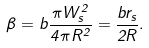<formula> <loc_0><loc_0><loc_500><loc_500>\beta = b \frac { \pi W _ { s } ^ { 2 } } { 4 \pi R ^ { 2 } } = \frac { b r _ { s } } { 2 R } .</formula> 